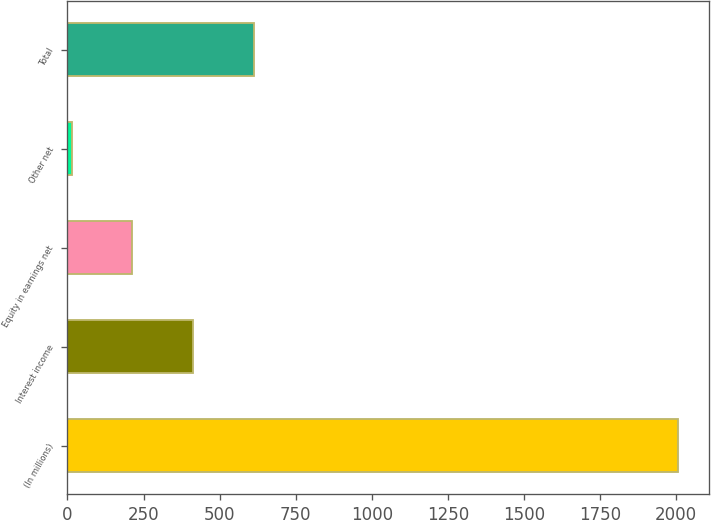Convert chart to OTSL. <chart><loc_0><loc_0><loc_500><loc_500><bar_chart><fcel>(In millions)<fcel>Interest income<fcel>Equity in earnings net<fcel>Other net<fcel>Total<nl><fcel>2006<fcel>412.4<fcel>213.2<fcel>14<fcel>611.6<nl></chart> 